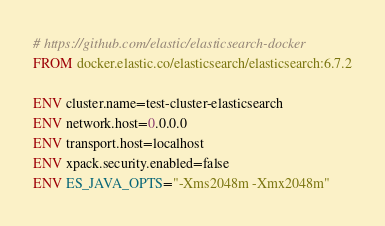Convert code to text. <code><loc_0><loc_0><loc_500><loc_500><_Dockerfile_># https://github.com/elastic/elasticsearch-docker
FROM docker.elastic.co/elasticsearch/elasticsearch:6.7.2

ENV cluster.name=test-cluster-elasticsearch
ENV network.host=0.0.0.0
ENV transport.host=localhost
ENV xpack.security.enabled=false
ENV ES_JAVA_OPTS="-Xms2048m -Xmx2048m"</code> 